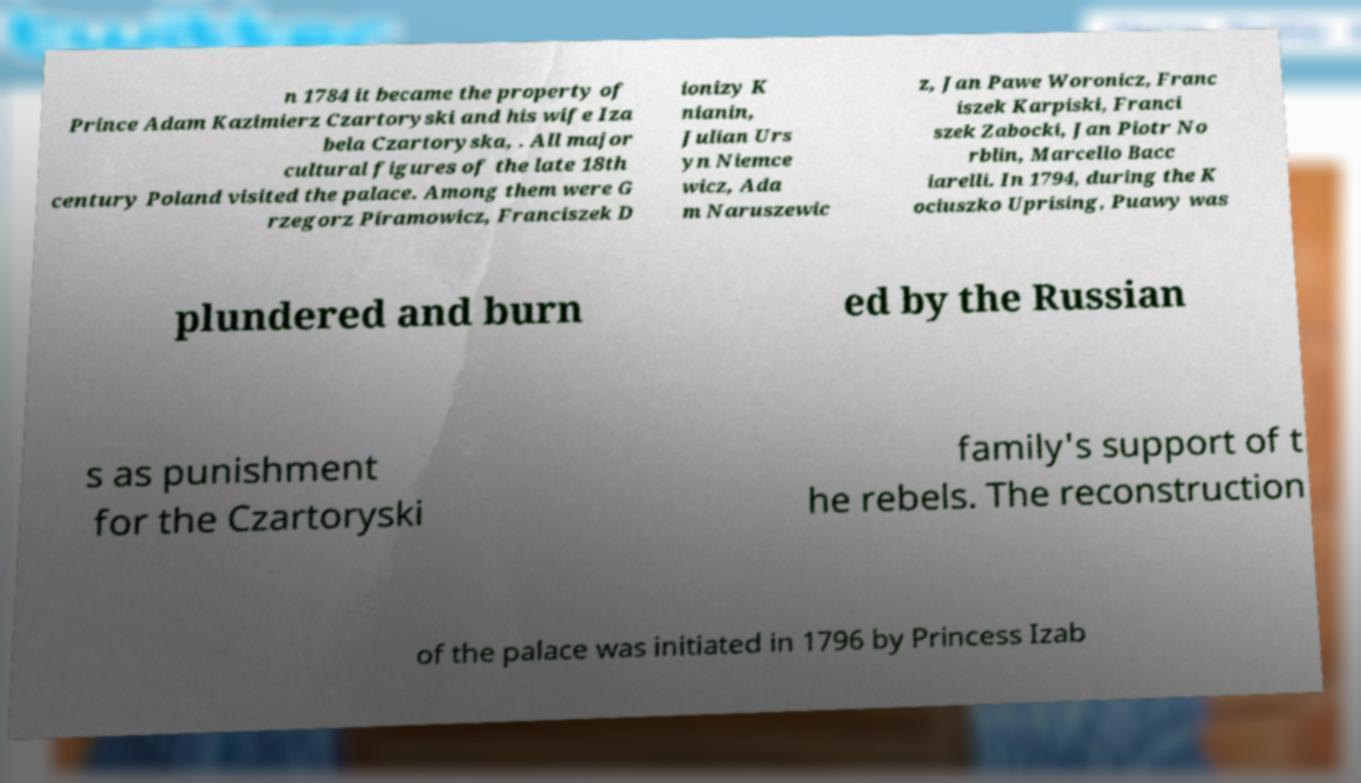For documentation purposes, I need the text within this image transcribed. Could you provide that? n 1784 it became the property of Prince Adam Kazimierz Czartoryski and his wife Iza bela Czartoryska, . All major cultural figures of the late 18th century Poland visited the palace. Among them were G rzegorz Piramowicz, Franciszek D ionizy K nianin, Julian Urs yn Niemce wicz, Ada m Naruszewic z, Jan Pawe Woronicz, Franc iszek Karpiski, Franci szek Zabocki, Jan Piotr No rblin, Marcello Bacc iarelli. In 1794, during the K ociuszko Uprising, Puawy was plundered and burn ed by the Russian s as punishment for the Czartoryski family's support of t he rebels. The reconstruction of the palace was initiated in 1796 by Princess Izab 